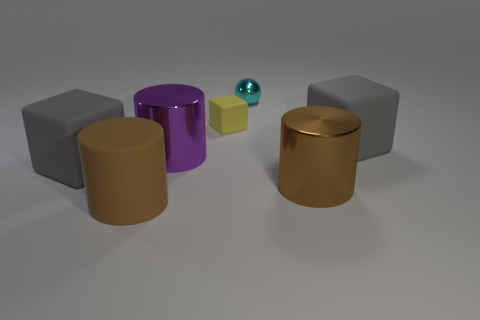What is the shape of the matte object behind the rubber cube that is to the right of the big brown metal object?
Offer a terse response. Cube. There is a metallic object left of the tiny yellow matte thing; is it the same size as the brown thing that is in front of the large brown shiny cylinder?
Provide a succinct answer. Yes. Are there any other tiny cyan spheres that have the same material as the small sphere?
Your response must be concise. No. What size is the metal thing that is the same color as the matte cylinder?
Provide a short and direct response. Large. Are there any brown metal objects that are on the left side of the large gray cube that is in front of the big matte thing that is to the right of the brown metallic cylinder?
Provide a succinct answer. No. There is a tiny metal thing; are there any tiny metal spheres behind it?
Offer a terse response. No. How many large cubes are right of the big matte cube that is left of the purple metallic cylinder?
Make the answer very short. 1. Does the yellow block have the same size as the cylinder right of the tiny cyan ball?
Give a very brief answer. No. Are there any small rubber cubes that have the same color as the tiny shiny thing?
Make the answer very short. No. What size is the purple thing that is made of the same material as the small cyan object?
Provide a short and direct response. Large. 